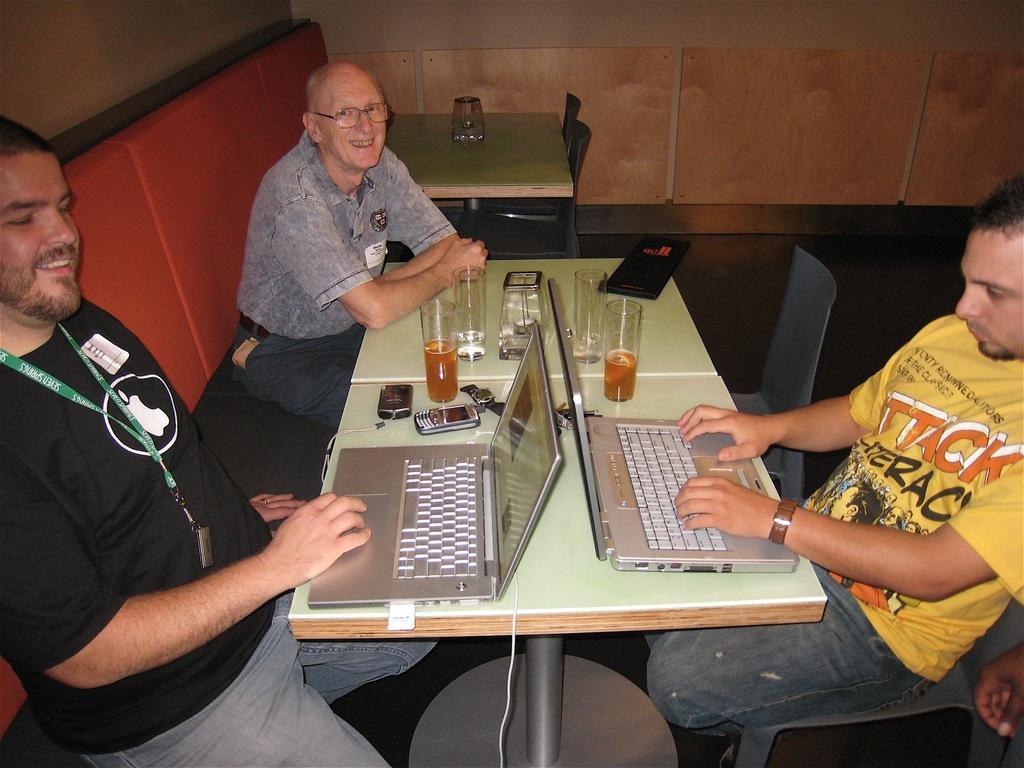Could you give a brief overview of what you see in this image? This picture is clicked inside a room. There are three men in this room, two sitting on the sofa and one on the chair. On the right corner of the picture, we see man in yellow t-shirt is operating laptop. Opposite to him, we see a man in black t-shirt wearing ID card is also operating a laptop and he is smiling. Beside him, we see an old man in grey t-shirt is laughing and in front of them, we see a table on which glass, mobile phone, laptop, watch and book is placed on it. Behind them, we see another table which is green is color and behind the table, we see a wall it is brown in color. 